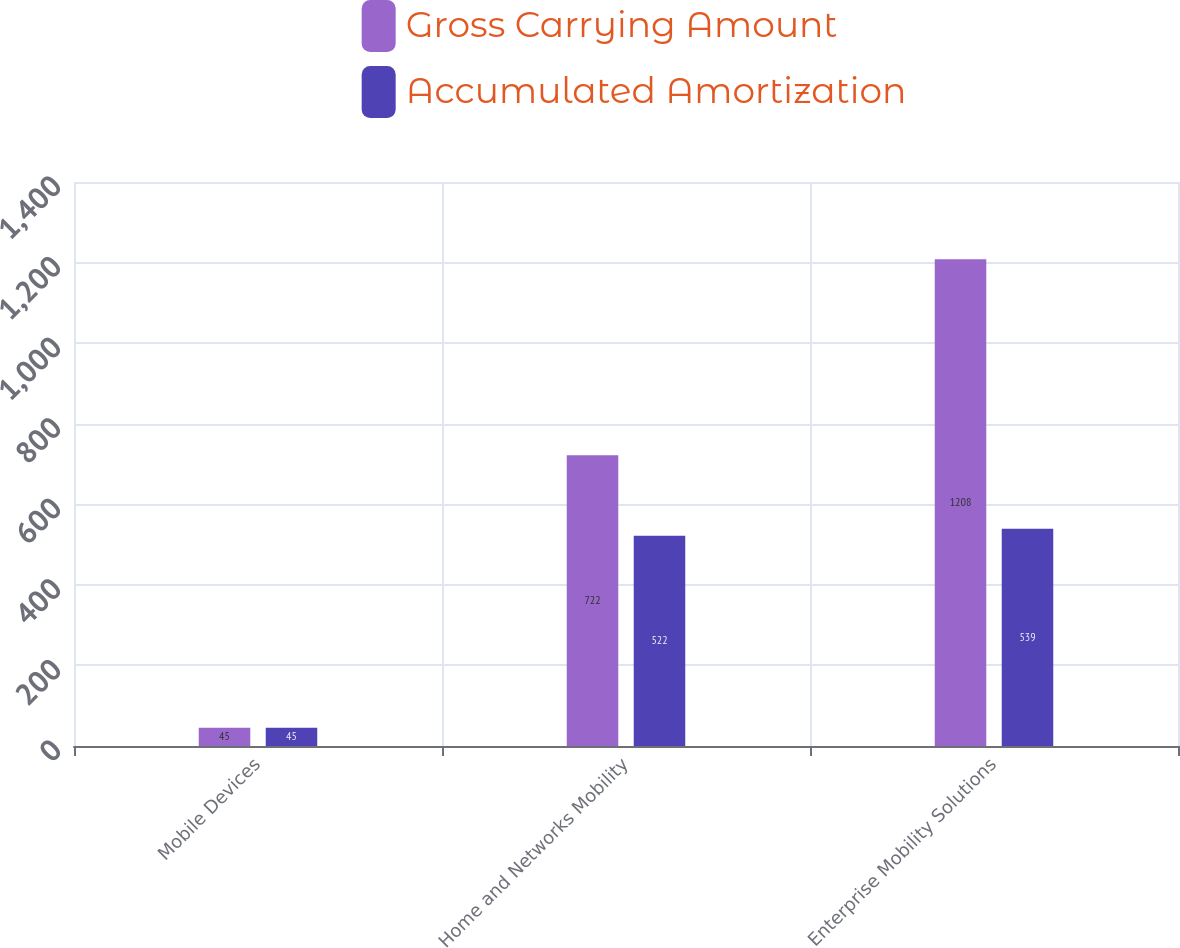Convert chart to OTSL. <chart><loc_0><loc_0><loc_500><loc_500><stacked_bar_chart><ecel><fcel>Mobile Devices<fcel>Home and Networks Mobility<fcel>Enterprise Mobility Solutions<nl><fcel>Gross Carrying Amount<fcel>45<fcel>722<fcel>1208<nl><fcel>Accumulated Amortization<fcel>45<fcel>522<fcel>539<nl></chart> 